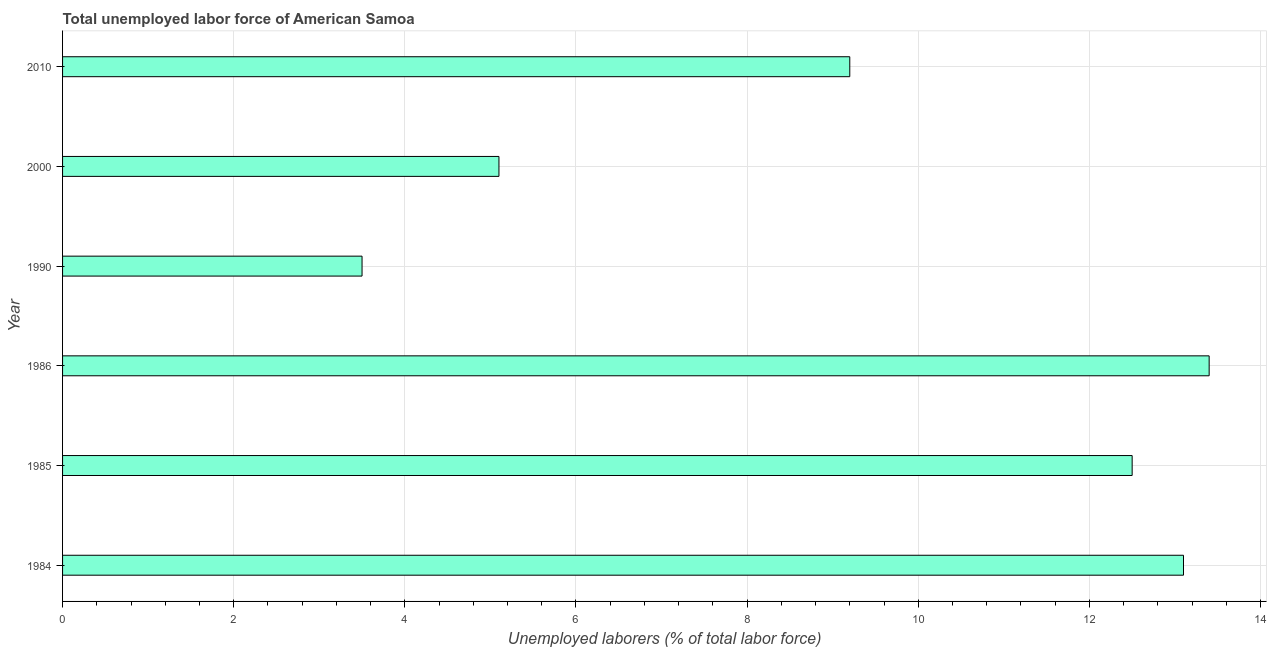Does the graph contain grids?
Make the answer very short. Yes. What is the title of the graph?
Offer a terse response. Total unemployed labor force of American Samoa. What is the label or title of the X-axis?
Provide a succinct answer. Unemployed laborers (% of total labor force). Across all years, what is the maximum total unemployed labour force?
Keep it short and to the point. 13.4. In which year was the total unemployed labour force maximum?
Offer a terse response. 1986. In which year was the total unemployed labour force minimum?
Ensure brevity in your answer.  1990. What is the sum of the total unemployed labour force?
Ensure brevity in your answer.  56.8. What is the average total unemployed labour force per year?
Give a very brief answer. 9.47. What is the median total unemployed labour force?
Offer a terse response. 10.85. What is the ratio of the total unemployed labour force in 1986 to that in 1990?
Keep it short and to the point. 3.83. Is the difference between the total unemployed labour force in 1985 and 2010 greater than the difference between any two years?
Offer a very short reply. No. Is the sum of the total unemployed labour force in 1986 and 2010 greater than the maximum total unemployed labour force across all years?
Provide a short and direct response. Yes. In how many years, is the total unemployed labour force greater than the average total unemployed labour force taken over all years?
Provide a short and direct response. 3. How many bars are there?
Keep it short and to the point. 6. What is the Unemployed laborers (% of total labor force) of 1984?
Ensure brevity in your answer.  13.1. What is the Unemployed laborers (% of total labor force) of 1986?
Give a very brief answer. 13.4. What is the Unemployed laborers (% of total labor force) in 2000?
Ensure brevity in your answer.  5.1. What is the Unemployed laborers (% of total labor force) of 2010?
Provide a short and direct response. 9.2. What is the difference between the Unemployed laborers (% of total labor force) in 1984 and 1985?
Provide a short and direct response. 0.6. What is the difference between the Unemployed laborers (% of total labor force) in 1984 and 1986?
Your response must be concise. -0.3. What is the difference between the Unemployed laborers (% of total labor force) in 1984 and 1990?
Provide a short and direct response. 9.6. What is the difference between the Unemployed laborers (% of total labor force) in 1984 and 2000?
Make the answer very short. 8. What is the difference between the Unemployed laborers (% of total labor force) in 1985 and 1990?
Offer a terse response. 9. What is the difference between the Unemployed laborers (% of total labor force) in 1985 and 2000?
Offer a very short reply. 7.4. What is the difference between the Unemployed laborers (% of total labor force) in 1986 and 2000?
Offer a terse response. 8.3. What is the difference between the Unemployed laborers (% of total labor force) in 1986 and 2010?
Your answer should be very brief. 4.2. What is the difference between the Unemployed laborers (% of total labor force) in 1990 and 2000?
Your answer should be compact. -1.6. What is the difference between the Unemployed laborers (% of total labor force) in 2000 and 2010?
Ensure brevity in your answer.  -4.1. What is the ratio of the Unemployed laborers (% of total labor force) in 1984 to that in 1985?
Keep it short and to the point. 1.05. What is the ratio of the Unemployed laborers (% of total labor force) in 1984 to that in 1990?
Your answer should be compact. 3.74. What is the ratio of the Unemployed laborers (% of total labor force) in 1984 to that in 2000?
Your answer should be compact. 2.57. What is the ratio of the Unemployed laborers (% of total labor force) in 1984 to that in 2010?
Keep it short and to the point. 1.42. What is the ratio of the Unemployed laborers (% of total labor force) in 1985 to that in 1986?
Make the answer very short. 0.93. What is the ratio of the Unemployed laborers (% of total labor force) in 1985 to that in 1990?
Your response must be concise. 3.57. What is the ratio of the Unemployed laborers (% of total labor force) in 1985 to that in 2000?
Ensure brevity in your answer.  2.45. What is the ratio of the Unemployed laborers (% of total labor force) in 1985 to that in 2010?
Offer a terse response. 1.36. What is the ratio of the Unemployed laborers (% of total labor force) in 1986 to that in 1990?
Ensure brevity in your answer.  3.83. What is the ratio of the Unemployed laborers (% of total labor force) in 1986 to that in 2000?
Provide a succinct answer. 2.63. What is the ratio of the Unemployed laborers (% of total labor force) in 1986 to that in 2010?
Keep it short and to the point. 1.46. What is the ratio of the Unemployed laborers (% of total labor force) in 1990 to that in 2000?
Your response must be concise. 0.69. What is the ratio of the Unemployed laborers (% of total labor force) in 1990 to that in 2010?
Your response must be concise. 0.38. What is the ratio of the Unemployed laborers (% of total labor force) in 2000 to that in 2010?
Your answer should be compact. 0.55. 